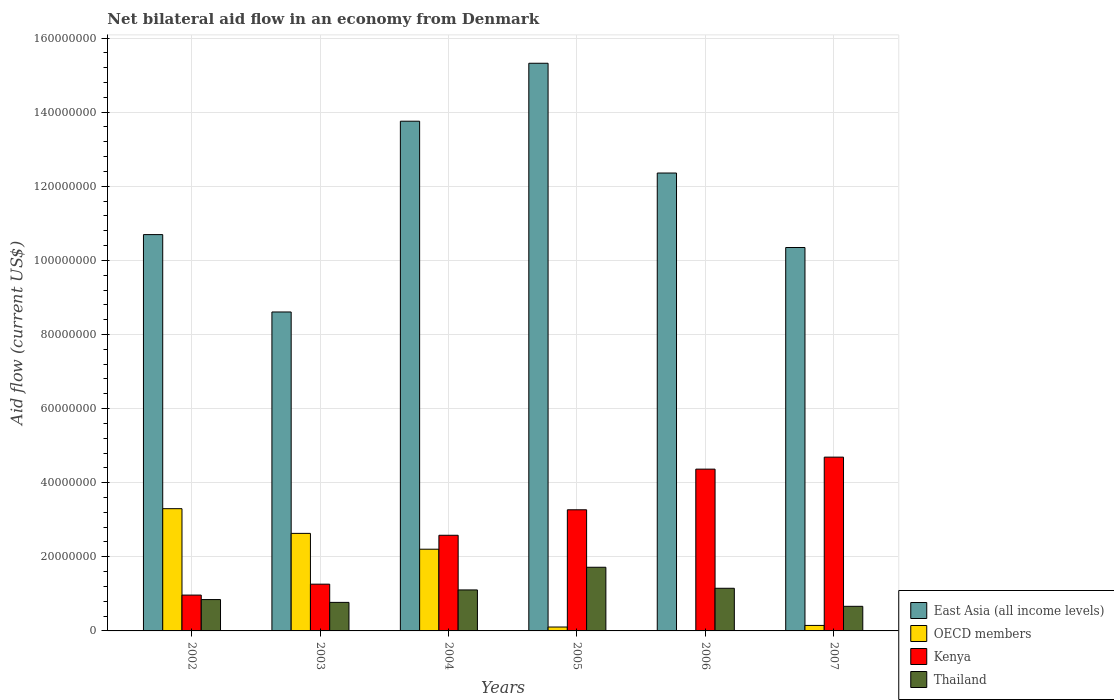How many different coloured bars are there?
Your response must be concise. 4. How many groups of bars are there?
Ensure brevity in your answer.  6. Are the number of bars on each tick of the X-axis equal?
Ensure brevity in your answer.  Yes. How many bars are there on the 6th tick from the left?
Offer a very short reply. 4. What is the label of the 4th group of bars from the left?
Make the answer very short. 2005. What is the net bilateral aid flow in OECD members in 2007?
Make the answer very short. 1.48e+06. Across all years, what is the maximum net bilateral aid flow in East Asia (all income levels)?
Your answer should be compact. 1.53e+08. Across all years, what is the minimum net bilateral aid flow in OECD members?
Keep it short and to the point. 1.10e+05. What is the total net bilateral aid flow in Kenya in the graph?
Your response must be concise. 1.71e+08. What is the difference between the net bilateral aid flow in OECD members in 2002 and that in 2003?
Give a very brief answer. 6.67e+06. What is the difference between the net bilateral aid flow in East Asia (all income levels) in 2006 and the net bilateral aid flow in Thailand in 2004?
Make the answer very short. 1.13e+08. What is the average net bilateral aid flow in OECD members per year?
Make the answer very short. 1.40e+07. In the year 2007, what is the difference between the net bilateral aid flow in Thailand and net bilateral aid flow in East Asia (all income levels)?
Your answer should be compact. -9.68e+07. What is the ratio of the net bilateral aid flow in Kenya in 2002 to that in 2007?
Your answer should be compact. 0.21. Is the difference between the net bilateral aid flow in Thailand in 2003 and 2006 greater than the difference between the net bilateral aid flow in East Asia (all income levels) in 2003 and 2006?
Make the answer very short. Yes. What is the difference between the highest and the second highest net bilateral aid flow in OECD members?
Keep it short and to the point. 6.67e+06. What is the difference between the highest and the lowest net bilateral aid flow in Thailand?
Ensure brevity in your answer.  1.05e+07. Is the sum of the net bilateral aid flow in East Asia (all income levels) in 2003 and 2006 greater than the maximum net bilateral aid flow in OECD members across all years?
Keep it short and to the point. Yes. What does the 3rd bar from the left in 2007 represents?
Provide a succinct answer. Kenya. What does the 2nd bar from the right in 2005 represents?
Your answer should be very brief. Kenya. How many years are there in the graph?
Your answer should be very brief. 6. What is the difference between two consecutive major ticks on the Y-axis?
Your response must be concise. 2.00e+07. Are the values on the major ticks of Y-axis written in scientific E-notation?
Make the answer very short. No. Does the graph contain any zero values?
Ensure brevity in your answer.  No. Where does the legend appear in the graph?
Make the answer very short. Bottom right. How many legend labels are there?
Offer a very short reply. 4. What is the title of the graph?
Your answer should be very brief. Net bilateral aid flow in an economy from Denmark. Does "Ukraine" appear as one of the legend labels in the graph?
Your answer should be compact. No. What is the label or title of the X-axis?
Ensure brevity in your answer.  Years. What is the Aid flow (current US$) of East Asia (all income levels) in 2002?
Your answer should be compact. 1.07e+08. What is the Aid flow (current US$) in OECD members in 2002?
Provide a succinct answer. 3.30e+07. What is the Aid flow (current US$) of Kenya in 2002?
Your answer should be very brief. 9.67e+06. What is the Aid flow (current US$) in Thailand in 2002?
Give a very brief answer. 8.46e+06. What is the Aid flow (current US$) in East Asia (all income levels) in 2003?
Offer a terse response. 8.61e+07. What is the Aid flow (current US$) in OECD members in 2003?
Make the answer very short. 2.63e+07. What is the Aid flow (current US$) of Kenya in 2003?
Make the answer very short. 1.26e+07. What is the Aid flow (current US$) in Thailand in 2003?
Keep it short and to the point. 7.70e+06. What is the Aid flow (current US$) in East Asia (all income levels) in 2004?
Your answer should be very brief. 1.38e+08. What is the Aid flow (current US$) in OECD members in 2004?
Your answer should be compact. 2.20e+07. What is the Aid flow (current US$) in Kenya in 2004?
Ensure brevity in your answer.  2.58e+07. What is the Aid flow (current US$) in Thailand in 2004?
Provide a short and direct response. 1.11e+07. What is the Aid flow (current US$) of East Asia (all income levels) in 2005?
Provide a short and direct response. 1.53e+08. What is the Aid flow (current US$) in OECD members in 2005?
Make the answer very short. 1.05e+06. What is the Aid flow (current US$) in Kenya in 2005?
Ensure brevity in your answer.  3.27e+07. What is the Aid flow (current US$) of Thailand in 2005?
Your answer should be very brief. 1.72e+07. What is the Aid flow (current US$) of East Asia (all income levels) in 2006?
Make the answer very short. 1.24e+08. What is the Aid flow (current US$) of OECD members in 2006?
Give a very brief answer. 1.10e+05. What is the Aid flow (current US$) in Kenya in 2006?
Your answer should be very brief. 4.37e+07. What is the Aid flow (current US$) of Thailand in 2006?
Offer a very short reply. 1.15e+07. What is the Aid flow (current US$) of East Asia (all income levels) in 2007?
Keep it short and to the point. 1.03e+08. What is the Aid flow (current US$) in OECD members in 2007?
Provide a short and direct response. 1.48e+06. What is the Aid flow (current US$) of Kenya in 2007?
Make the answer very short. 4.69e+07. What is the Aid flow (current US$) of Thailand in 2007?
Ensure brevity in your answer.  6.64e+06. Across all years, what is the maximum Aid flow (current US$) in East Asia (all income levels)?
Keep it short and to the point. 1.53e+08. Across all years, what is the maximum Aid flow (current US$) of OECD members?
Your response must be concise. 3.30e+07. Across all years, what is the maximum Aid flow (current US$) in Kenya?
Make the answer very short. 4.69e+07. Across all years, what is the maximum Aid flow (current US$) in Thailand?
Keep it short and to the point. 1.72e+07. Across all years, what is the minimum Aid flow (current US$) in East Asia (all income levels)?
Keep it short and to the point. 8.61e+07. Across all years, what is the minimum Aid flow (current US$) of OECD members?
Offer a terse response. 1.10e+05. Across all years, what is the minimum Aid flow (current US$) of Kenya?
Provide a short and direct response. 9.67e+06. Across all years, what is the minimum Aid flow (current US$) in Thailand?
Keep it short and to the point. 6.64e+06. What is the total Aid flow (current US$) in East Asia (all income levels) in the graph?
Provide a succinct answer. 7.11e+08. What is the total Aid flow (current US$) in OECD members in the graph?
Your response must be concise. 8.40e+07. What is the total Aid flow (current US$) of Kenya in the graph?
Your response must be concise. 1.71e+08. What is the total Aid flow (current US$) of Thailand in the graph?
Ensure brevity in your answer.  6.26e+07. What is the difference between the Aid flow (current US$) in East Asia (all income levels) in 2002 and that in 2003?
Your response must be concise. 2.09e+07. What is the difference between the Aid flow (current US$) in OECD members in 2002 and that in 2003?
Make the answer very short. 6.67e+06. What is the difference between the Aid flow (current US$) of Kenya in 2002 and that in 2003?
Your answer should be compact. -2.95e+06. What is the difference between the Aid flow (current US$) in Thailand in 2002 and that in 2003?
Give a very brief answer. 7.60e+05. What is the difference between the Aid flow (current US$) of East Asia (all income levels) in 2002 and that in 2004?
Give a very brief answer. -3.06e+07. What is the difference between the Aid flow (current US$) of OECD members in 2002 and that in 2004?
Provide a succinct answer. 1.09e+07. What is the difference between the Aid flow (current US$) of Kenya in 2002 and that in 2004?
Ensure brevity in your answer.  -1.61e+07. What is the difference between the Aid flow (current US$) in Thailand in 2002 and that in 2004?
Your response must be concise. -2.60e+06. What is the difference between the Aid flow (current US$) in East Asia (all income levels) in 2002 and that in 2005?
Provide a succinct answer. -4.62e+07. What is the difference between the Aid flow (current US$) of OECD members in 2002 and that in 2005?
Offer a very short reply. 3.19e+07. What is the difference between the Aid flow (current US$) in Kenya in 2002 and that in 2005?
Offer a very short reply. -2.30e+07. What is the difference between the Aid flow (current US$) in Thailand in 2002 and that in 2005?
Provide a succinct answer. -8.72e+06. What is the difference between the Aid flow (current US$) of East Asia (all income levels) in 2002 and that in 2006?
Give a very brief answer. -1.66e+07. What is the difference between the Aid flow (current US$) of OECD members in 2002 and that in 2006?
Provide a short and direct response. 3.29e+07. What is the difference between the Aid flow (current US$) of Kenya in 2002 and that in 2006?
Ensure brevity in your answer.  -3.40e+07. What is the difference between the Aid flow (current US$) in Thailand in 2002 and that in 2006?
Ensure brevity in your answer.  -3.05e+06. What is the difference between the Aid flow (current US$) of East Asia (all income levels) in 2002 and that in 2007?
Offer a terse response. 3.48e+06. What is the difference between the Aid flow (current US$) in OECD members in 2002 and that in 2007?
Make the answer very short. 3.15e+07. What is the difference between the Aid flow (current US$) of Kenya in 2002 and that in 2007?
Provide a short and direct response. -3.72e+07. What is the difference between the Aid flow (current US$) in Thailand in 2002 and that in 2007?
Keep it short and to the point. 1.82e+06. What is the difference between the Aid flow (current US$) in East Asia (all income levels) in 2003 and that in 2004?
Offer a terse response. -5.15e+07. What is the difference between the Aid flow (current US$) in OECD members in 2003 and that in 2004?
Your answer should be compact. 4.27e+06. What is the difference between the Aid flow (current US$) in Kenya in 2003 and that in 2004?
Make the answer very short. -1.32e+07. What is the difference between the Aid flow (current US$) in Thailand in 2003 and that in 2004?
Provide a short and direct response. -3.36e+06. What is the difference between the Aid flow (current US$) of East Asia (all income levels) in 2003 and that in 2005?
Your response must be concise. -6.71e+07. What is the difference between the Aid flow (current US$) of OECD members in 2003 and that in 2005?
Your answer should be compact. 2.53e+07. What is the difference between the Aid flow (current US$) of Kenya in 2003 and that in 2005?
Keep it short and to the point. -2.01e+07. What is the difference between the Aid flow (current US$) in Thailand in 2003 and that in 2005?
Provide a short and direct response. -9.48e+06. What is the difference between the Aid flow (current US$) in East Asia (all income levels) in 2003 and that in 2006?
Make the answer very short. -3.75e+07. What is the difference between the Aid flow (current US$) of OECD members in 2003 and that in 2006?
Make the answer very short. 2.62e+07. What is the difference between the Aid flow (current US$) in Kenya in 2003 and that in 2006?
Keep it short and to the point. -3.10e+07. What is the difference between the Aid flow (current US$) in Thailand in 2003 and that in 2006?
Give a very brief answer. -3.81e+06. What is the difference between the Aid flow (current US$) of East Asia (all income levels) in 2003 and that in 2007?
Your response must be concise. -1.74e+07. What is the difference between the Aid flow (current US$) of OECD members in 2003 and that in 2007?
Your answer should be compact. 2.48e+07. What is the difference between the Aid flow (current US$) in Kenya in 2003 and that in 2007?
Make the answer very short. -3.43e+07. What is the difference between the Aid flow (current US$) of Thailand in 2003 and that in 2007?
Provide a short and direct response. 1.06e+06. What is the difference between the Aid flow (current US$) in East Asia (all income levels) in 2004 and that in 2005?
Your answer should be compact. -1.56e+07. What is the difference between the Aid flow (current US$) in OECD members in 2004 and that in 2005?
Ensure brevity in your answer.  2.10e+07. What is the difference between the Aid flow (current US$) of Kenya in 2004 and that in 2005?
Keep it short and to the point. -6.88e+06. What is the difference between the Aid flow (current US$) in Thailand in 2004 and that in 2005?
Provide a succinct answer. -6.12e+06. What is the difference between the Aid flow (current US$) in East Asia (all income levels) in 2004 and that in 2006?
Give a very brief answer. 1.40e+07. What is the difference between the Aid flow (current US$) in OECD members in 2004 and that in 2006?
Your answer should be compact. 2.19e+07. What is the difference between the Aid flow (current US$) in Kenya in 2004 and that in 2006?
Provide a succinct answer. -1.78e+07. What is the difference between the Aid flow (current US$) in Thailand in 2004 and that in 2006?
Keep it short and to the point. -4.50e+05. What is the difference between the Aid flow (current US$) of East Asia (all income levels) in 2004 and that in 2007?
Your answer should be very brief. 3.41e+07. What is the difference between the Aid flow (current US$) of OECD members in 2004 and that in 2007?
Your response must be concise. 2.06e+07. What is the difference between the Aid flow (current US$) of Kenya in 2004 and that in 2007?
Your response must be concise. -2.11e+07. What is the difference between the Aid flow (current US$) in Thailand in 2004 and that in 2007?
Make the answer very short. 4.42e+06. What is the difference between the Aid flow (current US$) in East Asia (all income levels) in 2005 and that in 2006?
Provide a short and direct response. 2.96e+07. What is the difference between the Aid flow (current US$) of OECD members in 2005 and that in 2006?
Provide a succinct answer. 9.40e+05. What is the difference between the Aid flow (current US$) in Kenya in 2005 and that in 2006?
Give a very brief answer. -1.10e+07. What is the difference between the Aid flow (current US$) of Thailand in 2005 and that in 2006?
Provide a succinct answer. 5.67e+06. What is the difference between the Aid flow (current US$) of East Asia (all income levels) in 2005 and that in 2007?
Provide a short and direct response. 4.97e+07. What is the difference between the Aid flow (current US$) in OECD members in 2005 and that in 2007?
Offer a very short reply. -4.30e+05. What is the difference between the Aid flow (current US$) of Kenya in 2005 and that in 2007?
Your answer should be compact. -1.42e+07. What is the difference between the Aid flow (current US$) in Thailand in 2005 and that in 2007?
Your answer should be very brief. 1.05e+07. What is the difference between the Aid flow (current US$) of East Asia (all income levels) in 2006 and that in 2007?
Make the answer very short. 2.01e+07. What is the difference between the Aid flow (current US$) in OECD members in 2006 and that in 2007?
Provide a succinct answer. -1.37e+06. What is the difference between the Aid flow (current US$) of Kenya in 2006 and that in 2007?
Make the answer very short. -3.24e+06. What is the difference between the Aid flow (current US$) of Thailand in 2006 and that in 2007?
Offer a very short reply. 4.87e+06. What is the difference between the Aid flow (current US$) of East Asia (all income levels) in 2002 and the Aid flow (current US$) of OECD members in 2003?
Your answer should be very brief. 8.06e+07. What is the difference between the Aid flow (current US$) in East Asia (all income levels) in 2002 and the Aid flow (current US$) in Kenya in 2003?
Provide a short and direct response. 9.43e+07. What is the difference between the Aid flow (current US$) in East Asia (all income levels) in 2002 and the Aid flow (current US$) in Thailand in 2003?
Give a very brief answer. 9.92e+07. What is the difference between the Aid flow (current US$) in OECD members in 2002 and the Aid flow (current US$) in Kenya in 2003?
Your response must be concise. 2.04e+07. What is the difference between the Aid flow (current US$) of OECD members in 2002 and the Aid flow (current US$) of Thailand in 2003?
Make the answer very short. 2.53e+07. What is the difference between the Aid flow (current US$) in Kenya in 2002 and the Aid flow (current US$) in Thailand in 2003?
Make the answer very short. 1.97e+06. What is the difference between the Aid flow (current US$) of East Asia (all income levels) in 2002 and the Aid flow (current US$) of OECD members in 2004?
Offer a very short reply. 8.49e+07. What is the difference between the Aid flow (current US$) of East Asia (all income levels) in 2002 and the Aid flow (current US$) of Kenya in 2004?
Make the answer very short. 8.11e+07. What is the difference between the Aid flow (current US$) in East Asia (all income levels) in 2002 and the Aid flow (current US$) in Thailand in 2004?
Give a very brief answer. 9.59e+07. What is the difference between the Aid flow (current US$) in OECD members in 2002 and the Aid flow (current US$) in Kenya in 2004?
Provide a short and direct response. 7.18e+06. What is the difference between the Aid flow (current US$) of OECD members in 2002 and the Aid flow (current US$) of Thailand in 2004?
Keep it short and to the point. 2.19e+07. What is the difference between the Aid flow (current US$) in Kenya in 2002 and the Aid flow (current US$) in Thailand in 2004?
Keep it short and to the point. -1.39e+06. What is the difference between the Aid flow (current US$) of East Asia (all income levels) in 2002 and the Aid flow (current US$) of OECD members in 2005?
Your answer should be very brief. 1.06e+08. What is the difference between the Aid flow (current US$) in East Asia (all income levels) in 2002 and the Aid flow (current US$) in Kenya in 2005?
Offer a terse response. 7.43e+07. What is the difference between the Aid flow (current US$) in East Asia (all income levels) in 2002 and the Aid flow (current US$) in Thailand in 2005?
Offer a very short reply. 8.98e+07. What is the difference between the Aid flow (current US$) of OECD members in 2002 and the Aid flow (current US$) of Kenya in 2005?
Provide a short and direct response. 3.00e+05. What is the difference between the Aid flow (current US$) of OECD members in 2002 and the Aid flow (current US$) of Thailand in 2005?
Provide a short and direct response. 1.58e+07. What is the difference between the Aid flow (current US$) of Kenya in 2002 and the Aid flow (current US$) of Thailand in 2005?
Your answer should be compact. -7.51e+06. What is the difference between the Aid flow (current US$) of East Asia (all income levels) in 2002 and the Aid flow (current US$) of OECD members in 2006?
Keep it short and to the point. 1.07e+08. What is the difference between the Aid flow (current US$) in East Asia (all income levels) in 2002 and the Aid flow (current US$) in Kenya in 2006?
Your response must be concise. 6.33e+07. What is the difference between the Aid flow (current US$) of East Asia (all income levels) in 2002 and the Aid flow (current US$) of Thailand in 2006?
Make the answer very short. 9.54e+07. What is the difference between the Aid flow (current US$) in OECD members in 2002 and the Aid flow (current US$) in Kenya in 2006?
Your answer should be compact. -1.07e+07. What is the difference between the Aid flow (current US$) in OECD members in 2002 and the Aid flow (current US$) in Thailand in 2006?
Provide a succinct answer. 2.15e+07. What is the difference between the Aid flow (current US$) in Kenya in 2002 and the Aid flow (current US$) in Thailand in 2006?
Your answer should be very brief. -1.84e+06. What is the difference between the Aid flow (current US$) of East Asia (all income levels) in 2002 and the Aid flow (current US$) of OECD members in 2007?
Ensure brevity in your answer.  1.05e+08. What is the difference between the Aid flow (current US$) of East Asia (all income levels) in 2002 and the Aid flow (current US$) of Kenya in 2007?
Offer a terse response. 6.00e+07. What is the difference between the Aid flow (current US$) of East Asia (all income levels) in 2002 and the Aid flow (current US$) of Thailand in 2007?
Your answer should be very brief. 1.00e+08. What is the difference between the Aid flow (current US$) in OECD members in 2002 and the Aid flow (current US$) in Kenya in 2007?
Ensure brevity in your answer.  -1.39e+07. What is the difference between the Aid flow (current US$) of OECD members in 2002 and the Aid flow (current US$) of Thailand in 2007?
Keep it short and to the point. 2.64e+07. What is the difference between the Aid flow (current US$) in Kenya in 2002 and the Aid flow (current US$) in Thailand in 2007?
Your response must be concise. 3.03e+06. What is the difference between the Aid flow (current US$) in East Asia (all income levels) in 2003 and the Aid flow (current US$) in OECD members in 2004?
Offer a very short reply. 6.40e+07. What is the difference between the Aid flow (current US$) in East Asia (all income levels) in 2003 and the Aid flow (current US$) in Kenya in 2004?
Provide a succinct answer. 6.03e+07. What is the difference between the Aid flow (current US$) of East Asia (all income levels) in 2003 and the Aid flow (current US$) of Thailand in 2004?
Provide a succinct answer. 7.50e+07. What is the difference between the Aid flow (current US$) in OECD members in 2003 and the Aid flow (current US$) in Kenya in 2004?
Make the answer very short. 5.10e+05. What is the difference between the Aid flow (current US$) in OECD members in 2003 and the Aid flow (current US$) in Thailand in 2004?
Offer a very short reply. 1.53e+07. What is the difference between the Aid flow (current US$) of Kenya in 2003 and the Aid flow (current US$) of Thailand in 2004?
Make the answer very short. 1.56e+06. What is the difference between the Aid flow (current US$) of East Asia (all income levels) in 2003 and the Aid flow (current US$) of OECD members in 2005?
Ensure brevity in your answer.  8.50e+07. What is the difference between the Aid flow (current US$) of East Asia (all income levels) in 2003 and the Aid flow (current US$) of Kenya in 2005?
Offer a very short reply. 5.34e+07. What is the difference between the Aid flow (current US$) of East Asia (all income levels) in 2003 and the Aid flow (current US$) of Thailand in 2005?
Offer a terse response. 6.89e+07. What is the difference between the Aid flow (current US$) in OECD members in 2003 and the Aid flow (current US$) in Kenya in 2005?
Offer a very short reply. -6.37e+06. What is the difference between the Aid flow (current US$) of OECD members in 2003 and the Aid flow (current US$) of Thailand in 2005?
Provide a short and direct response. 9.14e+06. What is the difference between the Aid flow (current US$) of Kenya in 2003 and the Aid flow (current US$) of Thailand in 2005?
Offer a terse response. -4.56e+06. What is the difference between the Aid flow (current US$) of East Asia (all income levels) in 2003 and the Aid flow (current US$) of OECD members in 2006?
Ensure brevity in your answer.  8.60e+07. What is the difference between the Aid flow (current US$) of East Asia (all income levels) in 2003 and the Aid flow (current US$) of Kenya in 2006?
Offer a terse response. 4.24e+07. What is the difference between the Aid flow (current US$) in East Asia (all income levels) in 2003 and the Aid flow (current US$) in Thailand in 2006?
Ensure brevity in your answer.  7.46e+07. What is the difference between the Aid flow (current US$) of OECD members in 2003 and the Aid flow (current US$) of Kenya in 2006?
Offer a terse response. -1.73e+07. What is the difference between the Aid flow (current US$) in OECD members in 2003 and the Aid flow (current US$) in Thailand in 2006?
Your response must be concise. 1.48e+07. What is the difference between the Aid flow (current US$) in Kenya in 2003 and the Aid flow (current US$) in Thailand in 2006?
Make the answer very short. 1.11e+06. What is the difference between the Aid flow (current US$) of East Asia (all income levels) in 2003 and the Aid flow (current US$) of OECD members in 2007?
Keep it short and to the point. 8.46e+07. What is the difference between the Aid flow (current US$) in East Asia (all income levels) in 2003 and the Aid flow (current US$) in Kenya in 2007?
Give a very brief answer. 3.92e+07. What is the difference between the Aid flow (current US$) in East Asia (all income levels) in 2003 and the Aid flow (current US$) in Thailand in 2007?
Make the answer very short. 7.94e+07. What is the difference between the Aid flow (current US$) in OECD members in 2003 and the Aid flow (current US$) in Kenya in 2007?
Offer a very short reply. -2.06e+07. What is the difference between the Aid flow (current US$) in OECD members in 2003 and the Aid flow (current US$) in Thailand in 2007?
Your answer should be compact. 1.97e+07. What is the difference between the Aid flow (current US$) in Kenya in 2003 and the Aid flow (current US$) in Thailand in 2007?
Offer a very short reply. 5.98e+06. What is the difference between the Aid flow (current US$) of East Asia (all income levels) in 2004 and the Aid flow (current US$) of OECD members in 2005?
Your answer should be compact. 1.36e+08. What is the difference between the Aid flow (current US$) of East Asia (all income levels) in 2004 and the Aid flow (current US$) of Kenya in 2005?
Give a very brief answer. 1.05e+08. What is the difference between the Aid flow (current US$) in East Asia (all income levels) in 2004 and the Aid flow (current US$) in Thailand in 2005?
Offer a terse response. 1.20e+08. What is the difference between the Aid flow (current US$) of OECD members in 2004 and the Aid flow (current US$) of Kenya in 2005?
Offer a terse response. -1.06e+07. What is the difference between the Aid flow (current US$) of OECD members in 2004 and the Aid flow (current US$) of Thailand in 2005?
Provide a succinct answer. 4.87e+06. What is the difference between the Aid flow (current US$) of Kenya in 2004 and the Aid flow (current US$) of Thailand in 2005?
Provide a short and direct response. 8.63e+06. What is the difference between the Aid flow (current US$) of East Asia (all income levels) in 2004 and the Aid flow (current US$) of OECD members in 2006?
Keep it short and to the point. 1.37e+08. What is the difference between the Aid flow (current US$) in East Asia (all income levels) in 2004 and the Aid flow (current US$) in Kenya in 2006?
Offer a terse response. 9.39e+07. What is the difference between the Aid flow (current US$) of East Asia (all income levels) in 2004 and the Aid flow (current US$) of Thailand in 2006?
Provide a succinct answer. 1.26e+08. What is the difference between the Aid flow (current US$) in OECD members in 2004 and the Aid flow (current US$) in Kenya in 2006?
Provide a short and direct response. -2.16e+07. What is the difference between the Aid flow (current US$) in OECD members in 2004 and the Aid flow (current US$) in Thailand in 2006?
Your answer should be compact. 1.05e+07. What is the difference between the Aid flow (current US$) of Kenya in 2004 and the Aid flow (current US$) of Thailand in 2006?
Make the answer very short. 1.43e+07. What is the difference between the Aid flow (current US$) in East Asia (all income levels) in 2004 and the Aid flow (current US$) in OECD members in 2007?
Give a very brief answer. 1.36e+08. What is the difference between the Aid flow (current US$) of East Asia (all income levels) in 2004 and the Aid flow (current US$) of Kenya in 2007?
Your answer should be compact. 9.06e+07. What is the difference between the Aid flow (current US$) in East Asia (all income levels) in 2004 and the Aid flow (current US$) in Thailand in 2007?
Provide a succinct answer. 1.31e+08. What is the difference between the Aid flow (current US$) of OECD members in 2004 and the Aid flow (current US$) of Kenya in 2007?
Give a very brief answer. -2.48e+07. What is the difference between the Aid flow (current US$) of OECD members in 2004 and the Aid flow (current US$) of Thailand in 2007?
Provide a short and direct response. 1.54e+07. What is the difference between the Aid flow (current US$) in Kenya in 2004 and the Aid flow (current US$) in Thailand in 2007?
Your response must be concise. 1.92e+07. What is the difference between the Aid flow (current US$) of East Asia (all income levels) in 2005 and the Aid flow (current US$) of OECD members in 2006?
Provide a short and direct response. 1.53e+08. What is the difference between the Aid flow (current US$) in East Asia (all income levels) in 2005 and the Aid flow (current US$) in Kenya in 2006?
Provide a succinct answer. 1.10e+08. What is the difference between the Aid flow (current US$) in East Asia (all income levels) in 2005 and the Aid flow (current US$) in Thailand in 2006?
Keep it short and to the point. 1.42e+08. What is the difference between the Aid flow (current US$) in OECD members in 2005 and the Aid flow (current US$) in Kenya in 2006?
Give a very brief answer. -4.26e+07. What is the difference between the Aid flow (current US$) of OECD members in 2005 and the Aid flow (current US$) of Thailand in 2006?
Provide a succinct answer. -1.05e+07. What is the difference between the Aid flow (current US$) in Kenya in 2005 and the Aid flow (current US$) in Thailand in 2006?
Your response must be concise. 2.12e+07. What is the difference between the Aid flow (current US$) in East Asia (all income levels) in 2005 and the Aid flow (current US$) in OECD members in 2007?
Keep it short and to the point. 1.52e+08. What is the difference between the Aid flow (current US$) in East Asia (all income levels) in 2005 and the Aid flow (current US$) in Kenya in 2007?
Ensure brevity in your answer.  1.06e+08. What is the difference between the Aid flow (current US$) of East Asia (all income levels) in 2005 and the Aid flow (current US$) of Thailand in 2007?
Your answer should be very brief. 1.47e+08. What is the difference between the Aid flow (current US$) in OECD members in 2005 and the Aid flow (current US$) in Kenya in 2007?
Give a very brief answer. -4.58e+07. What is the difference between the Aid flow (current US$) of OECD members in 2005 and the Aid flow (current US$) of Thailand in 2007?
Your answer should be compact. -5.59e+06. What is the difference between the Aid flow (current US$) of Kenya in 2005 and the Aid flow (current US$) of Thailand in 2007?
Provide a short and direct response. 2.60e+07. What is the difference between the Aid flow (current US$) of East Asia (all income levels) in 2006 and the Aid flow (current US$) of OECD members in 2007?
Provide a short and direct response. 1.22e+08. What is the difference between the Aid flow (current US$) of East Asia (all income levels) in 2006 and the Aid flow (current US$) of Kenya in 2007?
Give a very brief answer. 7.67e+07. What is the difference between the Aid flow (current US$) of East Asia (all income levels) in 2006 and the Aid flow (current US$) of Thailand in 2007?
Make the answer very short. 1.17e+08. What is the difference between the Aid flow (current US$) in OECD members in 2006 and the Aid flow (current US$) in Kenya in 2007?
Give a very brief answer. -4.68e+07. What is the difference between the Aid flow (current US$) in OECD members in 2006 and the Aid flow (current US$) in Thailand in 2007?
Provide a succinct answer. -6.53e+06. What is the difference between the Aid flow (current US$) of Kenya in 2006 and the Aid flow (current US$) of Thailand in 2007?
Provide a short and direct response. 3.70e+07. What is the average Aid flow (current US$) in East Asia (all income levels) per year?
Give a very brief answer. 1.18e+08. What is the average Aid flow (current US$) of OECD members per year?
Keep it short and to the point. 1.40e+07. What is the average Aid flow (current US$) in Kenya per year?
Give a very brief answer. 2.86e+07. What is the average Aid flow (current US$) in Thailand per year?
Your answer should be compact. 1.04e+07. In the year 2002, what is the difference between the Aid flow (current US$) of East Asia (all income levels) and Aid flow (current US$) of OECD members?
Provide a short and direct response. 7.40e+07. In the year 2002, what is the difference between the Aid flow (current US$) of East Asia (all income levels) and Aid flow (current US$) of Kenya?
Provide a succinct answer. 9.73e+07. In the year 2002, what is the difference between the Aid flow (current US$) in East Asia (all income levels) and Aid flow (current US$) in Thailand?
Keep it short and to the point. 9.85e+07. In the year 2002, what is the difference between the Aid flow (current US$) of OECD members and Aid flow (current US$) of Kenya?
Offer a terse response. 2.33e+07. In the year 2002, what is the difference between the Aid flow (current US$) in OECD members and Aid flow (current US$) in Thailand?
Make the answer very short. 2.45e+07. In the year 2002, what is the difference between the Aid flow (current US$) of Kenya and Aid flow (current US$) of Thailand?
Offer a terse response. 1.21e+06. In the year 2003, what is the difference between the Aid flow (current US$) of East Asia (all income levels) and Aid flow (current US$) of OECD members?
Offer a very short reply. 5.98e+07. In the year 2003, what is the difference between the Aid flow (current US$) in East Asia (all income levels) and Aid flow (current US$) in Kenya?
Your response must be concise. 7.34e+07. In the year 2003, what is the difference between the Aid flow (current US$) of East Asia (all income levels) and Aid flow (current US$) of Thailand?
Provide a short and direct response. 7.84e+07. In the year 2003, what is the difference between the Aid flow (current US$) in OECD members and Aid flow (current US$) in Kenya?
Your answer should be compact. 1.37e+07. In the year 2003, what is the difference between the Aid flow (current US$) in OECD members and Aid flow (current US$) in Thailand?
Keep it short and to the point. 1.86e+07. In the year 2003, what is the difference between the Aid flow (current US$) in Kenya and Aid flow (current US$) in Thailand?
Give a very brief answer. 4.92e+06. In the year 2004, what is the difference between the Aid flow (current US$) in East Asia (all income levels) and Aid flow (current US$) in OECD members?
Give a very brief answer. 1.16e+08. In the year 2004, what is the difference between the Aid flow (current US$) in East Asia (all income levels) and Aid flow (current US$) in Kenya?
Make the answer very short. 1.12e+08. In the year 2004, what is the difference between the Aid flow (current US$) in East Asia (all income levels) and Aid flow (current US$) in Thailand?
Offer a very short reply. 1.26e+08. In the year 2004, what is the difference between the Aid flow (current US$) of OECD members and Aid flow (current US$) of Kenya?
Your answer should be compact. -3.76e+06. In the year 2004, what is the difference between the Aid flow (current US$) of OECD members and Aid flow (current US$) of Thailand?
Your answer should be very brief. 1.10e+07. In the year 2004, what is the difference between the Aid flow (current US$) of Kenya and Aid flow (current US$) of Thailand?
Keep it short and to the point. 1.48e+07. In the year 2005, what is the difference between the Aid flow (current US$) of East Asia (all income levels) and Aid flow (current US$) of OECD members?
Provide a short and direct response. 1.52e+08. In the year 2005, what is the difference between the Aid flow (current US$) in East Asia (all income levels) and Aid flow (current US$) in Kenya?
Make the answer very short. 1.20e+08. In the year 2005, what is the difference between the Aid flow (current US$) in East Asia (all income levels) and Aid flow (current US$) in Thailand?
Ensure brevity in your answer.  1.36e+08. In the year 2005, what is the difference between the Aid flow (current US$) of OECD members and Aid flow (current US$) of Kenya?
Your answer should be compact. -3.16e+07. In the year 2005, what is the difference between the Aid flow (current US$) of OECD members and Aid flow (current US$) of Thailand?
Your response must be concise. -1.61e+07. In the year 2005, what is the difference between the Aid flow (current US$) in Kenya and Aid flow (current US$) in Thailand?
Your answer should be very brief. 1.55e+07. In the year 2006, what is the difference between the Aid flow (current US$) in East Asia (all income levels) and Aid flow (current US$) in OECD members?
Provide a short and direct response. 1.23e+08. In the year 2006, what is the difference between the Aid flow (current US$) of East Asia (all income levels) and Aid flow (current US$) of Kenya?
Your answer should be very brief. 7.99e+07. In the year 2006, what is the difference between the Aid flow (current US$) in East Asia (all income levels) and Aid flow (current US$) in Thailand?
Provide a succinct answer. 1.12e+08. In the year 2006, what is the difference between the Aid flow (current US$) of OECD members and Aid flow (current US$) of Kenya?
Give a very brief answer. -4.36e+07. In the year 2006, what is the difference between the Aid flow (current US$) of OECD members and Aid flow (current US$) of Thailand?
Make the answer very short. -1.14e+07. In the year 2006, what is the difference between the Aid flow (current US$) in Kenya and Aid flow (current US$) in Thailand?
Make the answer very short. 3.22e+07. In the year 2007, what is the difference between the Aid flow (current US$) of East Asia (all income levels) and Aid flow (current US$) of OECD members?
Your response must be concise. 1.02e+08. In the year 2007, what is the difference between the Aid flow (current US$) of East Asia (all income levels) and Aid flow (current US$) of Kenya?
Your answer should be compact. 5.66e+07. In the year 2007, what is the difference between the Aid flow (current US$) of East Asia (all income levels) and Aid flow (current US$) of Thailand?
Offer a very short reply. 9.68e+07. In the year 2007, what is the difference between the Aid flow (current US$) of OECD members and Aid flow (current US$) of Kenya?
Offer a very short reply. -4.54e+07. In the year 2007, what is the difference between the Aid flow (current US$) of OECD members and Aid flow (current US$) of Thailand?
Provide a short and direct response. -5.16e+06. In the year 2007, what is the difference between the Aid flow (current US$) in Kenya and Aid flow (current US$) in Thailand?
Keep it short and to the point. 4.03e+07. What is the ratio of the Aid flow (current US$) in East Asia (all income levels) in 2002 to that in 2003?
Your answer should be very brief. 1.24. What is the ratio of the Aid flow (current US$) in OECD members in 2002 to that in 2003?
Provide a short and direct response. 1.25. What is the ratio of the Aid flow (current US$) in Kenya in 2002 to that in 2003?
Provide a short and direct response. 0.77. What is the ratio of the Aid flow (current US$) of Thailand in 2002 to that in 2003?
Offer a terse response. 1.1. What is the ratio of the Aid flow (current US$) of East Asia (all income levels) in 2002 to that in 2004?
Give a very brief answer. 0.78. What is the ratio of the Aid flow (current US$) of OECD members in 2002 to that in 2004?
Provide a short and direct response. 1.5. What is the ratio of the Aid flow (current US$) of Kenya in 2002 to that in 2004?
Ensure brevity in your answer.  0.37. What is the ratio of the Aid flow (current US$) of Thailand in 2002 to that in 2004?
Offer a very short reply. 0.76. What is the ratio of the Aid flow (current US$) of East Asia (all income levels) in 2002 to that in 2005?
Your response must be concise. 0.7. What is the ratio of the Aid flow (current US$) of OECD members in 2002 to that in 2005?
Your response must be concise. 31.42. What is the ratio of the Aid flow (current US$) of Kenya in 2002 to that in 2005?
Your answer should be compact. 0.3. What is the ratio of the Aid flow (current US$) of Thailand in 2002 to that in 2005?
Make the answer very short. 0.49. What is the ratio of the Aid flow (current US$) in East Asia (all income levels) in 2002 to that in 2006?
Your answer should be compact. 0.87. What is the ratio of the Aid flow (current US$) of OECD members in 2002 to that in 2006?
Your answer should be very brief. 299.91. What is the ratio of the Aid flow (current US$) of Kenya in 2002 to that in 2006?
Give a very brief answer. 0.22. What is the ratio of the Aid flow (current US$) of Thailand in 2002 to that in 2006?
Give a very brief answer. 0.73. What is the ratio of the Aid flow (current US$) in East Asia (all income levels) in 2002 to that in 2007?
Offer a terse response. 1.03. What is the ratio of the Aid flow (current US$) of OECD members in 2002 to that in 2007?
Provide a succinct answer. 22.29. What is the ratio of the Aid flow (current US$) of Kenya in 2002 to that in 2007?
Your answer should be compact. 0.21. What is the ratio of the Aid flow (current US$) of Thailand in 2002 to that in 2007?
Make the answer very short. 1.27. What is the ratio of the Aid flow (current US$) in East Asia (all income levels) in 2003 to that in 2004?
Offer a very short reply. 0.63. What is the ratio of the Aid flow (current US$) of OECD members in 2003 to that in 2004?
Offer a terse response. 1.19. What is the ratio of the Aid flow (current US$) of Kenya in 2003 to that in 2004?
Provide a short and direct response. 0.49. What is the ratio of the Aid flow (current US$) in Thailand in 2003 to that in 2004?
Keep it short and to the point. 0.7. What is the ratio of the Aid flow (current US$) of East Asia (all income levels) in 2003 to that in 2005?
Your response must be concise. 0.56. What is the ratio of the Aid flow (current US$) in OECD members in 2003 to that in 2005?
Keep it short and to the point. 25.07. What is the ratio of the Aid flow (current US$) of Kenya in 2003 to that in 2005?
Provide a short and direct response. 0.39. What is the ratio of the Aid flow (current US$) of Thailand in 2003 to that in 2005?
Give a very brief answer. 0.45. What is the ratio of the Aid flow (current US$) in East Asia (all income levels) in 2003 to that in 2006?
Keep it short and to the point. 0.7. What is the ratio of the Aid flow (current US$) of OECD members in 2003 to that in 2006?
Your answer should be compact. 239.27. What is the ratio of the Aid flow (current US$) in Kenya in 2003 to that in 2006?
Your answer should be very brief. 0.29. What is the ratio of the Aid flow (current US$) in Thailand in 2003 to that in 2006?
Make the answer very short. 0.67. What is the ratio of the Aid flow (current US$) in East Asia (all income levels) in 2003 to that in 2007?
Give a very brief answer. 0.83. What is the ratio of the Aid flow (current US$) in OECD members in 2003 to that in 2007?
Provide a short and direct response. 17.78. What is the ratio of the Aid flow (current US$) of Kenya in 2003 to that in 2007?
Make the answer very short. 0.27. What is the ratio of the Aid flow (current US$) in Thailand in 2003 to that in 2007?
Your answer should be compact. 1.16. What is the ratio of the Aid flow (current US$) in East Asia (all income levels) in 2004 to that in 2005?
Your answer should be compact. 0.9. What is the ratio of the Aid flow (current US$) of Kenya in 2004 to that in 2005?
Ensure brevity in your answer.  0.79. What is the ratio of the Aid flow (current US$) of Thailand in 2004 to that in 2005?
Your response must be concise. 0.64. What is the ratio of the Aid flow (current US$) of East Asia (all income levels) in 2004 to that in 2006?
Your response must be concise. 1.11. What is the ratio of the Aid flow (current US$) of OECD members in 2004 to that in 2006?
Offer a terse response. 200.45. What is the ratio of the Aid flow (current US$) in Kenya in 2004 to that in 2006?
Provide a succinct answer. 0.59. What is the ratio of the Aid flow (current US$) of Thailand in 2004 to that in 2006?
Your answer should be very brief. 0.96. What is the ratio of the Aid flow (current US$) of East Asia (all income levels) in 2004 to that in 2007?
Offer a terse response. 1.33. What is the ratio of the Aid flow (current US$) of OECD members in 2004 to that in 2007?
Your response must be concise. 14.9. What is the ratio of the Aid flow (current US$) of Kenya in 2004 to that in 2007?
Give a very brief answer. 0.55. What is the ratio of the Aid flow (current US$) in Thailand in 2004 to that in 2007?
Your answer should be compact. 1.67. What is the ratio of the Aid flow (current US$) of East Asia (all income levels) in 2005 to that in 2006?
Your answer should be very brief. 1.24. What is the ratio of the Aid flow (current US$) in OECD members in 2005 to that in 2006?
Offer a terse response. 9.55. What is the ratio of the Aid flow (current US$) of Kenya in 2005 to that in 2006?
Make the answer very short. 0.75. What is the ratio of the Aid flow (current US$) of Thailand in 2005 to that in 2006?
Your response must be concise. 1.49. What is the ratio of the Aid flow (current US$) in East Asia (all income levels) in 2005 to that in 2007?
Give a very brief answer. 1.48. What is the ratio of the Aid flow (current US$) of OECD members in 2005 to that in 2007?
Provide a succinct answer. 0.71. What is the ratio of the Aid flow (current US$) in Kenya in 2005 to that in 2007?
Your answer should be compact. 0.7. What is the ratio of the Aid flow (current US$) in Thailand in 2005 to that in 2007?
Your answer should be compact. 2.59. What is the ratio of the Aid flow (current US$) in East Asia (all income levels) in 2006 to that in 2007?
Provide a succinct answer. 1.19. What is the ratio of the Aid flow (current US$) in OECD members in 2006 to that in 2007?
Offer a terse response. 0.07. What is the ratio of the Aid flow (current US$) in Kenya in 2006 to that in 2007?
Keep it short and to the point. 0.93. What is the ratio of the Aid flow (current US$) of Thailand in 2006 to that in 2007?
Give a very brief answer. 1.73. What is the difference between the highest and the second highest Aid flow (current US$) in East Asia (all income levels)?
Make the answer very short. 1.56e+07. What is the difference between the highest and the second highest Aid flow (current US$) in OECD members?
Keep it short and to the point. 6.67e+06. What is the difference between the highest and the second highest Aid flow (current US$) of Kenya?
Ensure brevity in your answer.  3.24e+06. What is the difference between the highest and the second highest Aid flow (current US$) of Thailand?
Provide a short and direct response. 5.67e+06. What is the difference between the highest and the lowest Aid flow (current US$) of East Asia (all income levels)?
Provide a short and direct response. 6.71e+07. What is the difference between the highest and the lowest Aid flow (current US$) of OECD members?
Ensure brevity in your answer.  3.29e+07. What is the difference between the highest and the lowest Aid flow (current US$) of Kenya?
Your answer should be compact. 3.72e+07. What is the difference between the highest and the lowest Aid flow (current US$) in Thailand?
Your answer should be very brief. 1.05e+07. 